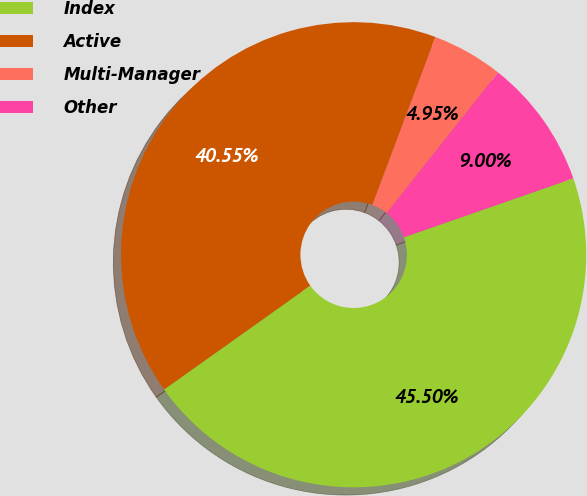<chart> <loc_0><loc_0><loc_500><loc_500><pie_chart><fcel>Index<fcel>Active<fcel>Multi-Manager<fcel>Other<nl><fcel>45.5%<fcel>40.55%<fcel>4.95%<fcel>9.0%<nl></chart> 